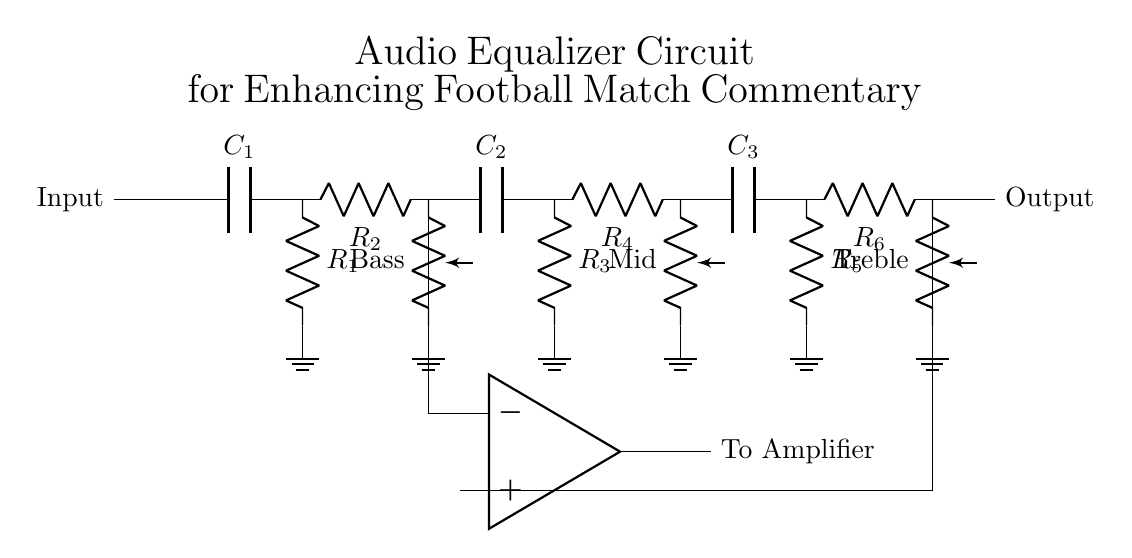What is the type of this circuit? The circuit is an audio equalizer filter that adjusts frequencies to enhance sound quality, particularly for commentary during football matches.
Answer: audio equalizer filter How many potentiometers are present in the circuit? The circuit has three potentiometers, each labeled for adjusting bass, mid, and treble frequencies.
Answer: three What is the function of the op-amp in this circuit? The operational amplifier (op-amp) serves to amplify the combined audio signal from different frequency sections before sending it to the amplifier.
Answer: amplify Which component is responsible for the bass adjustment? The bass adjustment is controlled by the potentiometer labeled "Bass," which is connected after the capacitor and resistors designed for low frequency.
Answer: Bass potentiometer What happens if you turn the treble potentiometer to maximum? Turning the treble potentiometer to maximum increases the high frequency response, allowing more of those frequencies to pass through, enhancing the clarity of commentary.
Answer: increases high frequencies What connects the output of this circuit to amplifiers? The output from the op-amp connects to the amplifiers, ensuring that the enhanced audio signal is strong enough for further amplification.
Answer: op-amp output Where do the input and output terminals of this circuit connect? The input terminal connects to the beginning of the audio circuit, while the output connects at the end, following the op-amp, directing the enhanced signal to the amplifier.
Answer: input and output terminals 